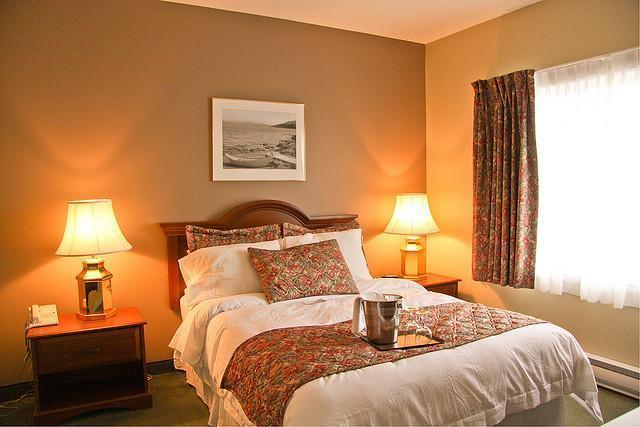How many umbrellas are there in this picture?
Give a very brief answer. 0. 